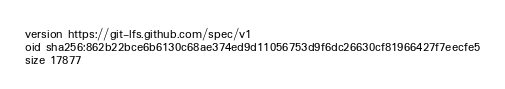Convert code to text. <code><loc_0><loc_0><loc_500><loc_500><_HTML_>version https://git-lfs.github.com/spec/v1
oid sha256:862b22bce6b6130c68ae374ed9d11056753d9f6dc26630cf81966427f7eecfe5
size 17877
</code> 